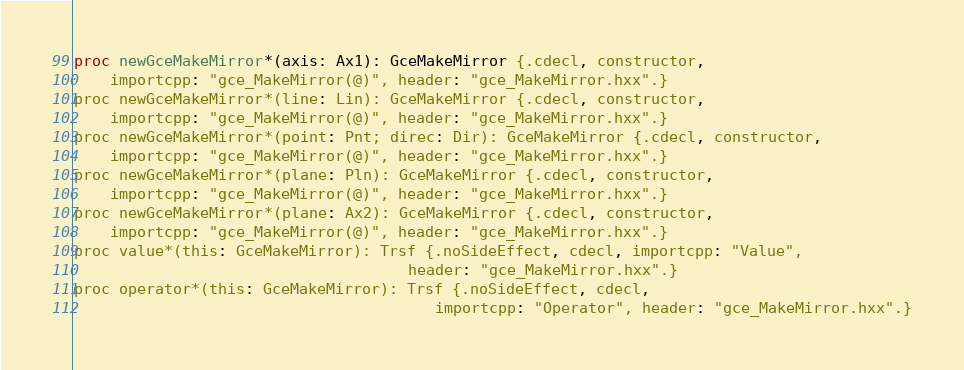Convert code to text. <code><loc_0><loc_0><loc_500><loc_500><_Nim_>proc newGceMakeMirror*(axis: Ax1): GceMakeMirror {.cdecl, constructor,
    importcpp: "gce_MakeMirror(@)", header: "gce_MakeMirror.hxx".}
proc newGceMakeMirror*(line: Lin): GceMakeMirror {.cdecl, constructor,
    importcpp: "gce_MakeMirror(@)", header: "gce_MakeMirror.hxx".}
proc newGceMakeMirror*(point: Pnt; direc: Dir): GceMakeMirror {.cdecl, constructor,
    importcpp: "gce_MakeMirror(@)", header: "gce_MakeMirror.hxx".}
proc newGceMakeMirror*(plane: Pln): GceMakeMirror {.cdecl, constructor,
    importcpp: "gce_MakeMirror(@)", header: "gce_MakeMirror.hxx".}
proc newGceMakeMirror*(plane: Ax2): GceMakeMirror {.cdecl, constructor,
    importcpp: "gce_MakeMirror(@)", header: "gce_MakeMirror.hxx".}
proc value*(this: GceMakeMirror): Trsf {.noSideEffect, cdecl, importcpp: "Value",
                                     header: "gce_MakeMirror.hxx".}
proc operator*(this: GceMakeMirror): Trsf {.noSideEffect, cdecl,
                                        importcpp: "Operator", header: "gce_MakeMirror.hxx".}</code> 